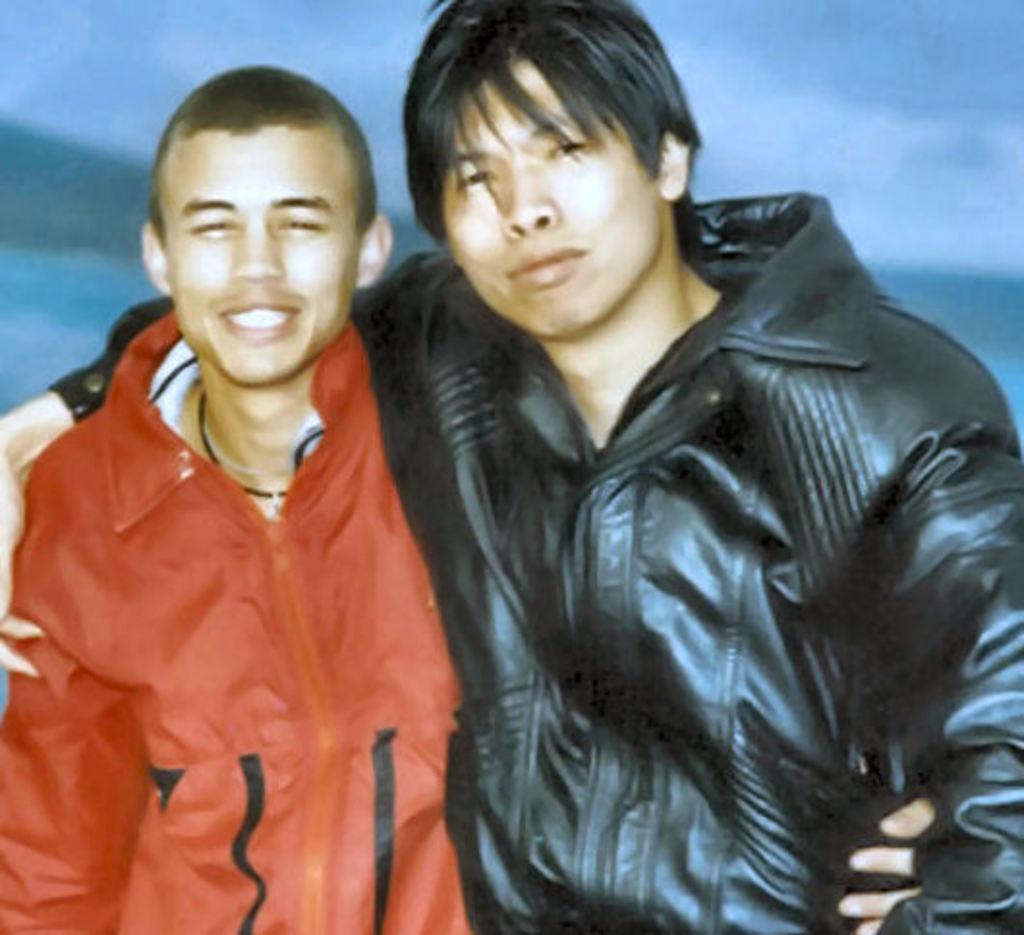In one or two sentences, can you explain what this image depicts? In this image there are two people standing with a smile on their face. 